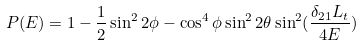Convert formula to latex. <formula><loc_0><loc_0><loc_500><loc_500>P ( E ) = 1 - \frac { 1 } { 2 } \sin ^ { 2 } 2 \phi - \cos ^ { 4 } \phi \sin ^ { 2 } 2 \theta \sin ^ { 2 } ( \frac { \delta _ { 2 1 } L _ { t } } { 4 E } )</formula> 